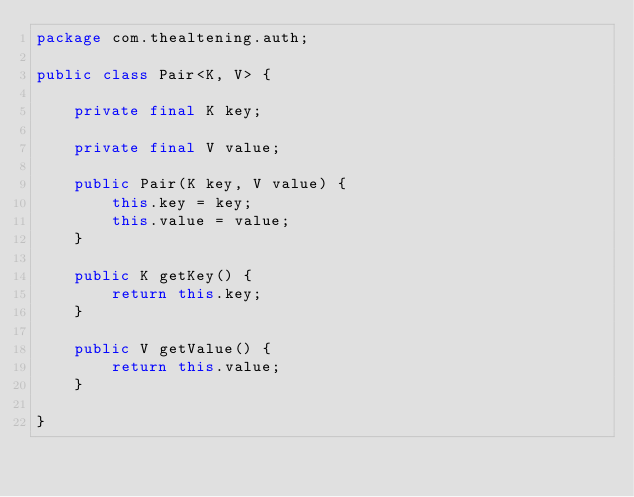<code> <loc_0><loc_0><loc_500><loc_500><_Java_>package com.thealtening.auth;

public class Pair<K, V> {

	private final K key;

	private final V value;

	public Pair(K key, V value) {
		this.key = key;
		this.value = value;
	}

	public K getKey() {
		return this.key;
	}

	public V getValue() {
		return this.value;
	}

}</code> 